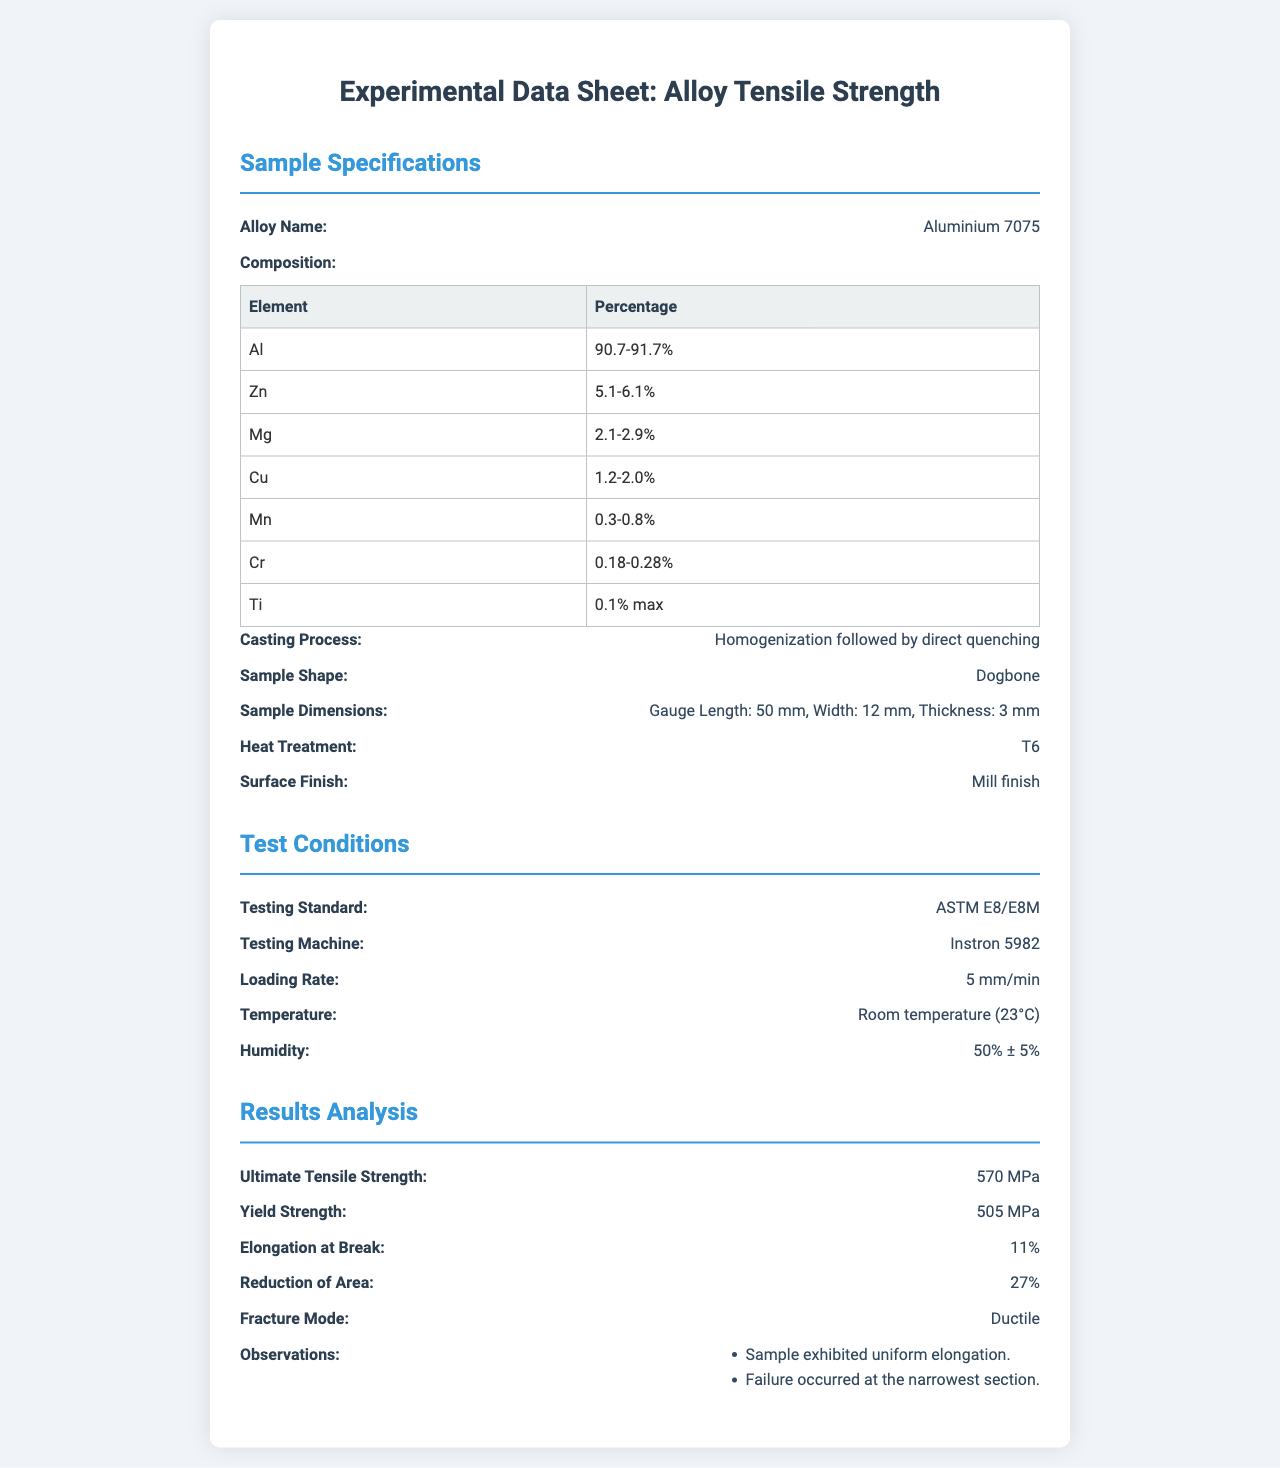What is the alloy name? The alloy name is stated under Sample Specifications, referring to the specific alloy tested for tensile strength.
Answer: Aluminium 7075 What is the ultimate tensile strength? The ultimate tensile strength is found in the Results Analysis section and refers to the maximum stress that the alloy can withstand.
Answer: 570 MPa What was the sample shape used in the tests? The sample shape is mentioned under Sample Specifications, which describes the form of the alloy used for testing.
Answer: Dogbone What is the loading rate used during testing? The loading rate is provided in the Test Conditions section, indicating how rapidly the load was applied during the test.
Answer: 5 mm/min What kind of heat treatment was applied to the sample? The heat treatment process is described in the Sample Specifications, outlining the thermal treatment the alloy underwent.
Answer: T6 What was the yield strength of the alloy? The yield strength is detailed in the Results Analysis and represents the stress at which the material begins to deform plastically.
Answer: 505 MPa What is the reduction of area observed during the test? The reduction of area is presented in the Results Analysis section and measures the decrease in cross-sectional area at fracture.
Answer: 27% Which testing standard was followed? The testing standard is specified in the Test Conditions, indicating the guidelines adhered to during the testing process.
Answer: ASTM E8/E8M What was the humidity level during the tests? The humidity level is found in the Test Conditions section, revealing the environmental conditions when the testing took place.
Answer: 50% ± 5% 